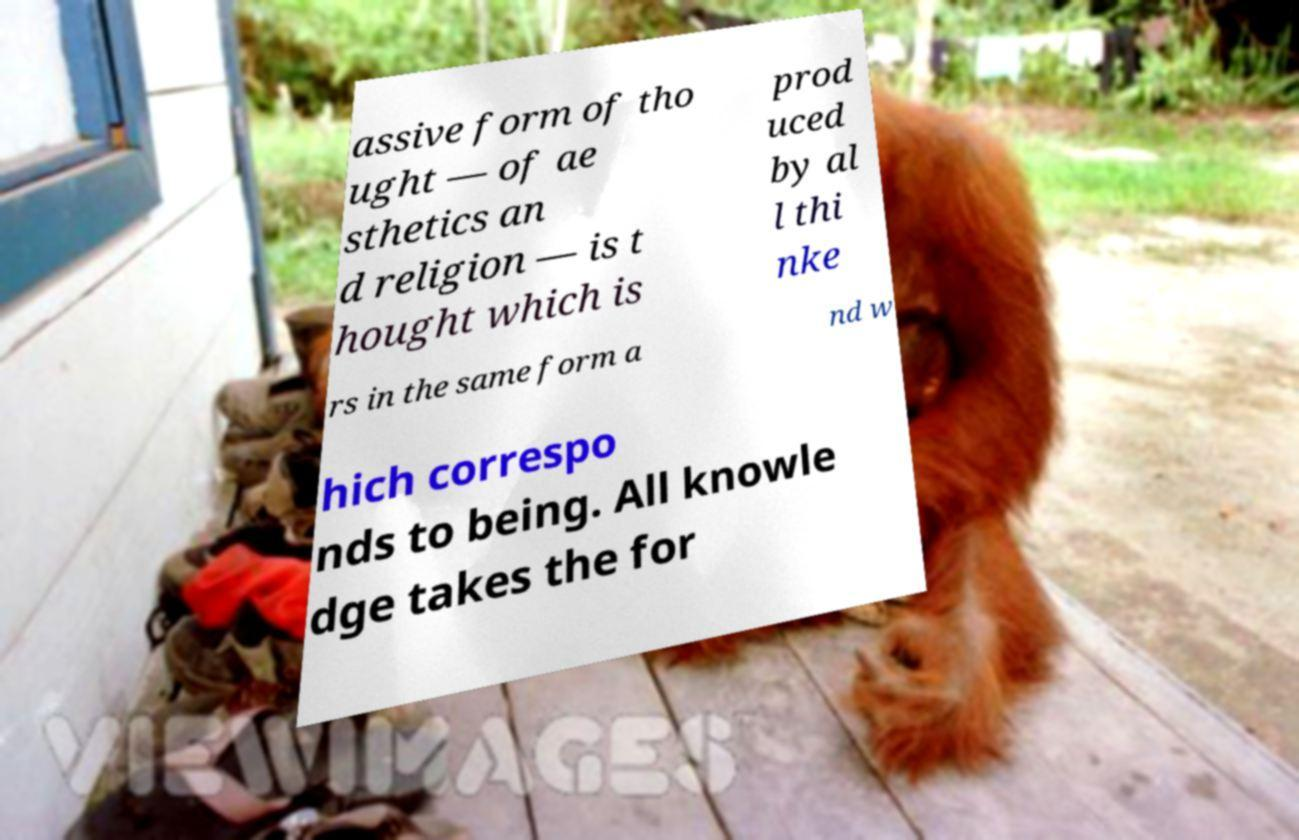What messages or text are displayed in this image? I need them in a readable, typed format. assive form of tho ught — of ae sthetics an d religion — is t hought which is prod uced by al l thi nke rs in the same form a nd w hich correspo nds to being. All knowle dge takes the for 